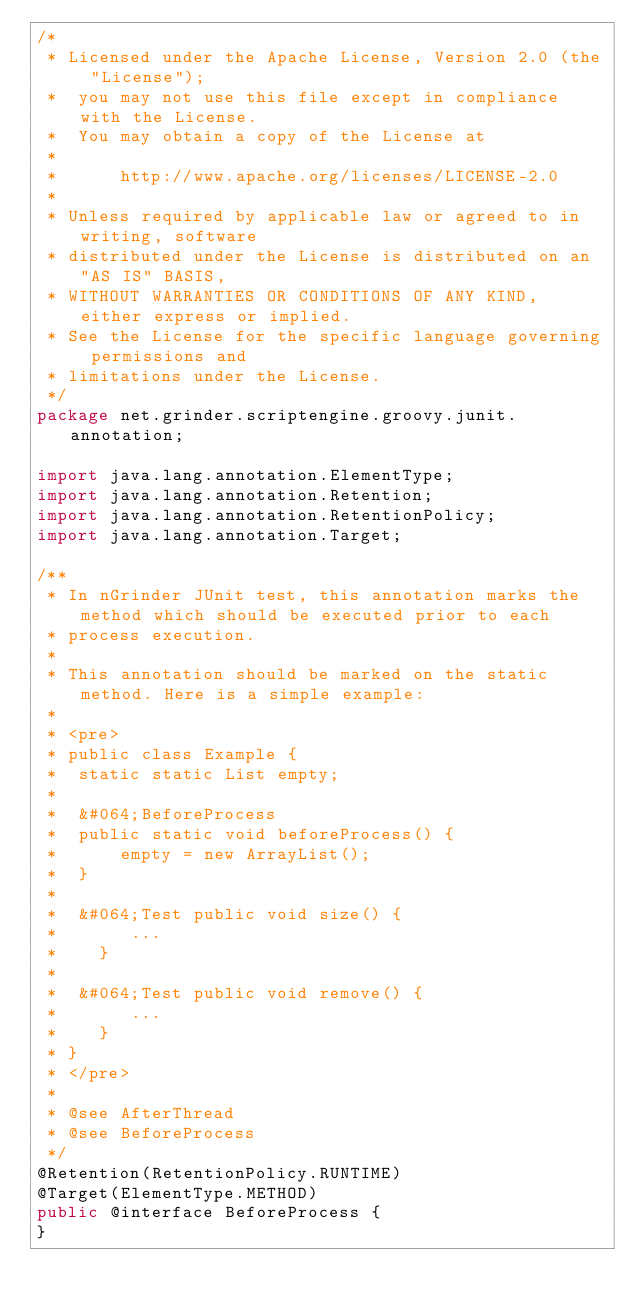Convert code to text. <code><loc_0><loc_0><loc_500><loc_500><_Java_>/* 
 * Licensed under the Apache License, Version 2.0 (the "License");
 *  you may not use this file except in compliance with the License.
 *  You may obtain a copy of the License at
 *
 *      http://www.apache.org/licenses/LICENSE-2.0
 *
 * Unless required by applicable law or agreed to in writing, software
 * distributed under the License is distributed on an "AS IS" BASIS,
 * WITHOUT WARRANTIES OR CONDITIONS OF ANY KIND, either express or implied.
 * See the License for the specific language governing permissions and
 * limitations under the License. 
 */
package net.grinder.scriptengine.groovy.junit.annotation;

import java.lang.annotation.ElementType;
import java.lang.annotation.Retention;
import java.lang.annotation.RetentionPolicy;
import java.lang.annotation.Target;

/**
 * In nGrinder JUnit test, this annotation marks the method which should be executed prior to each
 * process execution.
 * 
 * This annotation should be marked on the static method. Here is a simple example:
 * 
 * <pre>
 * public class Example {
 * 	static static List empty;
 * 
 * 	&#064;BeforeProcess
 * 	public static void beforeProcess() {
 * 		empty = new ArrayList();
 * 	}
 * 
 * 	&#064;Test public void size() {
 *       ...
 *    }
 * 
 * 	&#064;Test public void remove() {
 *       ...
 *    }
 * }
 * </pre>
 * 
 * @see AfterThread
 * @see BeforeProcess
 */
@Retention(RetentionPolicy.RUNTIME)
@Target(ElementType.METHOD)
public @interface BeforeProcess {
}
</code> 